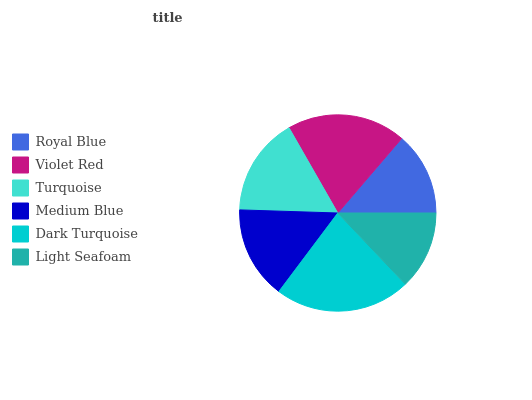Is Light Seafoam the minimum?
Answer yes or no. Yes. Is Dark Turquoise the maximum?
Answer yes or no. Yes. Is Violet Red the minimum?
Answer yes or no. No. Is Violet Red the maximum?
Answer yes or no. No. Is Violet Red greater than Royal Blue?
Answer yes or no. Yes. Is Royal Blue less than Violet Red?
Answer yes or no. Yes. Is Royal Blue greater than Violet Red?
Answer yes or no. No. Is Violet Red less than Royal Blue?
Answer yes or no. No. Is Turquoise the high median?
Answer yes or no. Yes. Is Medium Blue the low median?
Answer yes or no. Yes. Is Light Seafoam the high median?
Answer yes or no. No. Is Violet Red the low median?
Answer yes or no. No. 